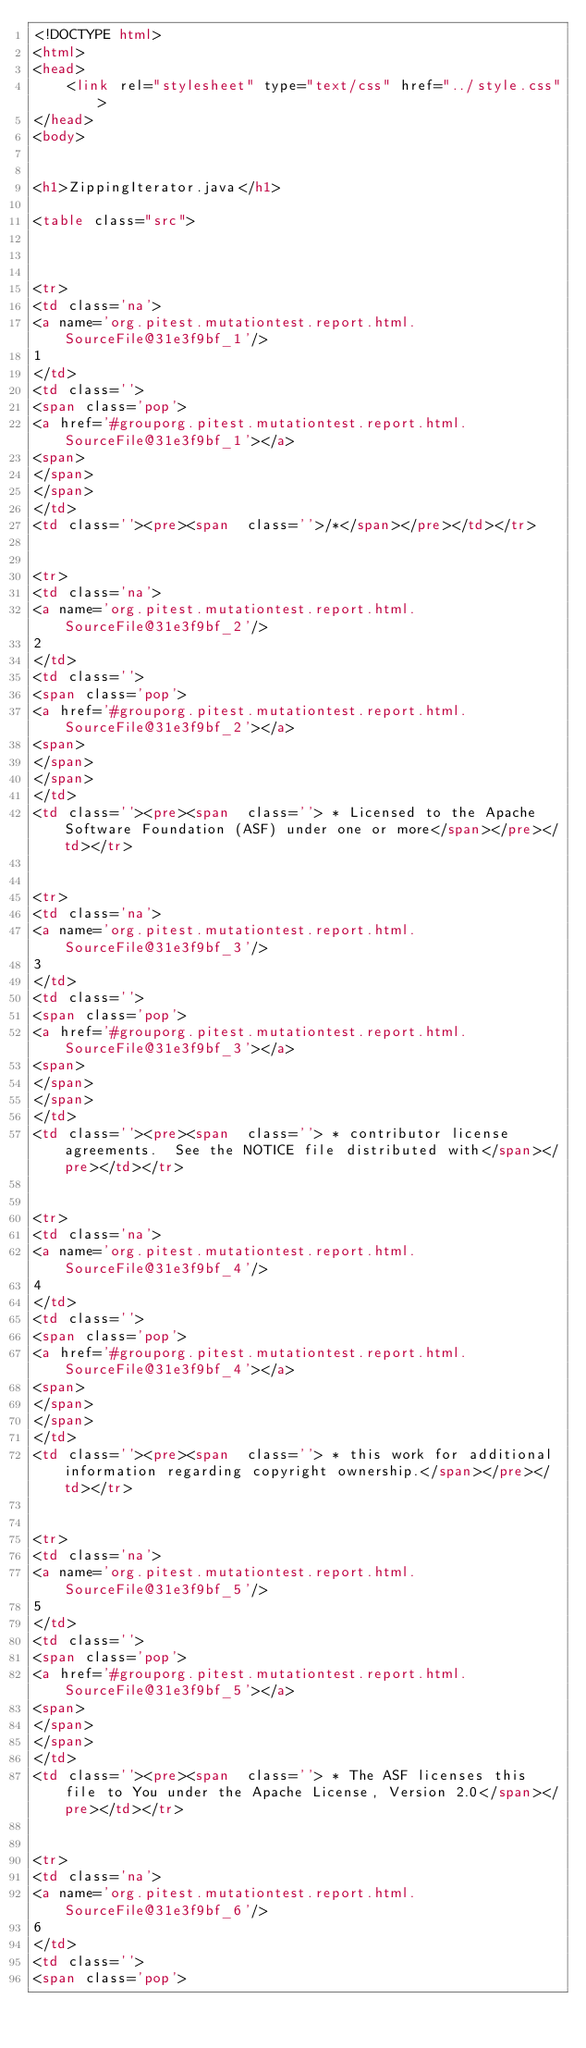<code> <loc_0><loc_0><loc_500><loc_500><_HTML_><!DOCTYPE html>
<html>
<head>
    <link rel="stylesheet" type="text/css" href="../style.css">
</head>
<body>


<h1>ZippingIterator.java</h1>

<table class="src">



<tr>
<td class='na'>
<a name='org.pitest.mutationtest.report.html.SourceFile@31e3f9bf_1'/>
1
</td>
<td class=''>
<span class='pop'>
<a href='#grouporg.pitest.mutationtest.report.html.SourceFile@31e3f9bf_1'></a>
<span>
</span>
</span>
</td>
<td class=''><pre><span  class=''>/*</span></pre></td></tr>


<tr>
<td class='na'>
<a name='org.pitest.mutationtest.report.html.SourceFile@31e3f9bf_2'/>
2
</td>
<td class=''>
<span class='pop'>
<a href='#grouporg.pitest.mutationtest.report.html.SourceFile@31e3f9bf_2'></a>
<span>
</span>
</span>
</td>
<td class=''><pre><span  class=''> * Licensed to the Apache Software Foundation (ASF) under one or more</span></pre></td></tr>


<tr>
<td class='na'>
<a name='org.pitest.mutationtest.report.html.SourceFile@31e3f9bf_3'/>
3
</td>
<td class=''>
<span class='pop'>
<a href='#grouporg.pitest.mutationtest.report.html.SourceFile@31e3f9bf_3'></a>
<span>
</span>
</span>
</td>
<td class=''><pre><span  class=''> * contributor license agreements.  See the NOTICE file distributed with</span></pre></td></tr>


<tr>
<td class='na'>
<a name='org.pitest.mutationtest.report.html.SourceFile@31e3f9bf_4'/>
4
</td>
<td class=''>
<span class='pop'>
<a href='#grouporg.pitest.mutationtest.report.html.SourceFile@31e3f9bf_4'></a>
<span>
</span>
</span>
</td>
<td class=''><pre><span  class=''> * this work for additional information regarding copyright ownership.</span></pre></td></tr>


<tr>
<td class='na'>
<a name='org.pitest.mutationtest.report.html.SourceFile@31e3f9bf_5'/>
5
</td>
<td class=''>
<span class='pop'>
<a href='#grouporg.pitest.mutationtest.report.html.SourceFile@31e3f9bf_5'></a>
<span>
</span>
</span>
</td>
<td class=''><pre><span  class=''> * The ASF licenses this file to You under the Apache License, Version 2.0</span></pre></td></tr>


<tr>
<td class='na'>
<a name='org.pitest.mutationtest.report.html.SourceFile@31e3f9bf_6'/>
6
</td>
<td class=''>
<span class='pop'></code> 